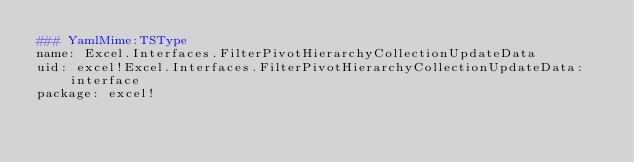Convert code to text. <code><loc_0><loc_0><loc_500><loc_500><_YAML_>### YamlMime:TSType
name: Excel.Interfaces.FilterPivotHierarchyCollectionUpdateData
uid: excel!Excel.Interfaces.FilterPivotHierarchyCollectionUpdateData:interface
package: excel!</code> 